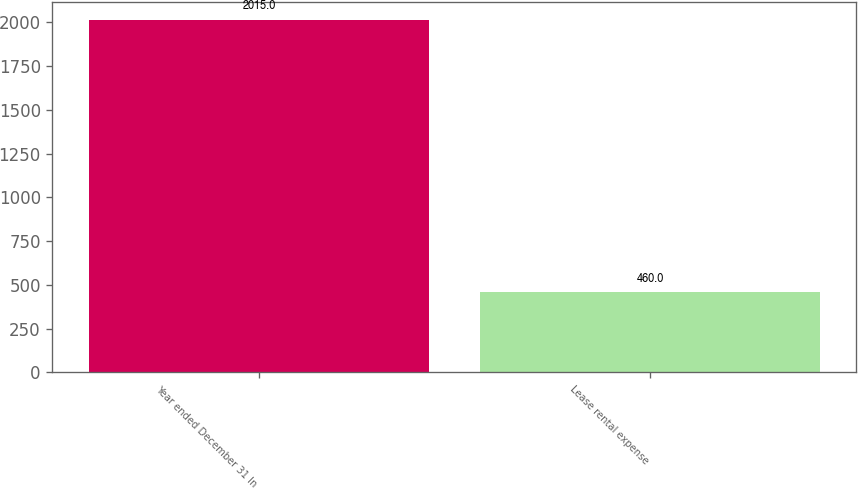Convert chart. <chart><loc_0><loc_0><loc_500><loc_500><bar_chart><fcel>Year ended December 31 In<fcel>Lease rental expense<nl><fcel>2015<fcel>460<nl></chart> 